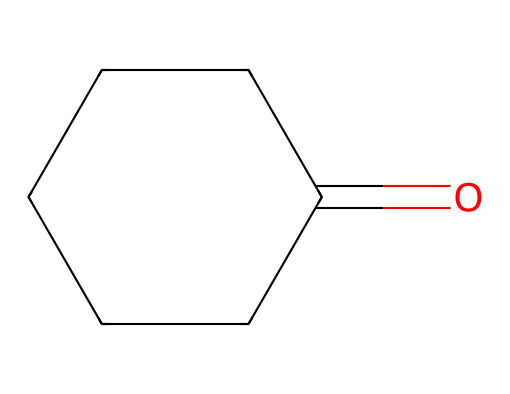What is the molecular formula of cyclohexanone? To determine the molecular formula from the SMILES representation O=C1CCCCC1, we identify the atoms present. The "O=" indicates there is one carbonyl oxygen, and "C1CCCCC1" indicates a cyclohexane ring made of six carbon atoms. Therefore, the total is six carbons and one oxygen, resulting in the molecular formula C6H10O.
Answer: C6H10O How many carbon atoms are in cyclohexanone? From the SMILES notation O=C1CCCCC1, we can count the carbon atoms in the cyclohexane ring, which includes 6 in total.
Answer: 6 What type of functional group is present in cyclohexanone? The "O=" in the SMILES notation indicates a carbonyl group (C=O). Specifically, since it's bound to a cycloalkane, it's identified as a ketone.
Answer: ketone What kind of hybridization do the carbon atoms in cyclohexanone exhibited? The carbon atoms involved in the cyclohexane ring are sp3 hybridized due to their four single bonds, while the carbonyl carbon is sp2 hybridized because it forms a double bond with oxygen.
Answer: sp3 and sp2 What is the general class of the compound represented by O=C1CCCCC1? The presence of a ring structure and single bonds, along with a carbonyl group, categorizes this compound as a cycloalkane derivative.
Answer: cycloalkane How many hydrogen atoms are in cyclohexanone? The molecular formula C6H10O indicates that there are 10 hydrogen atoms associated with the 6 carbon atoms and 1 oxygen atom, derived from the structure.
Answer: 10 Is cyclohexanone saturated or unsaturated? Considering the presence of a ring and the carbonyl group, it has single and double bonds, making it unsaturated.
Answer: unsaturated 